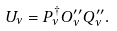<formula> <loc_0><loc_0><loc_500><loc_500>U _ { \nu } = P _ { \nu } ^ { \dagger } O _ { \nu } ^ { \prime \prime } Q _ { \nu } ^ { \prime \prime } .</formula> 